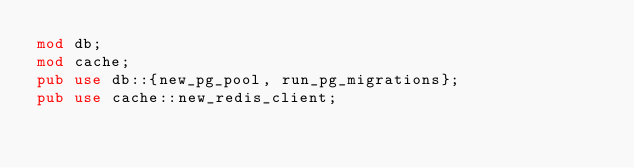<code> <loc_0><loc_0><loc_500><loc_500><_Rust_>mod db;
mod cache;
pub use db::{new_pg_pool, run_pg_migrations};
pub use cache::new_redis_client;
</code> 